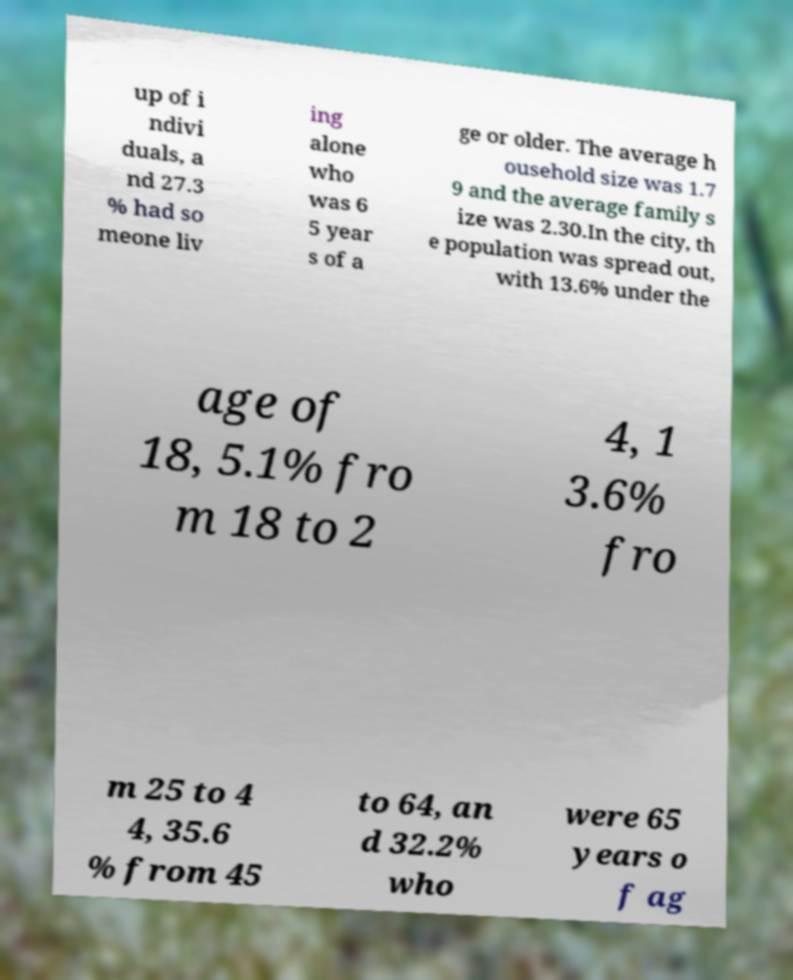There's text embedded in this image that I need extracted. Can you transcribe it verbatim? up of i ndivi duals, a nd 27.3 % had so meone liv ing alone who was 6 5 year s of a ge or older. The average h ousehold size was 1.7 9 and the average family s ize was 2.30.In the city, th e population was spread out, with 13.6% under the age of 18, 5.1% fro m 18 to 2 4, 1 3.6% fro m 25 to 4 4, 35.6 % from 45 to 64, an d 32.2% who were 65 years o f ag 